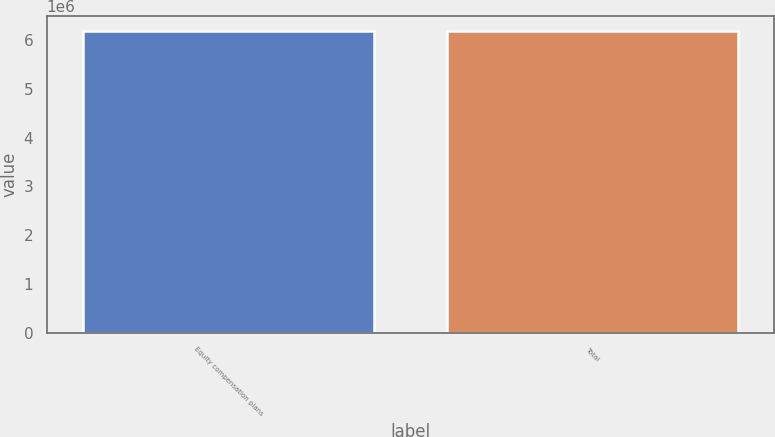Convert chart. <chart><loc_0><loc_0><loc_500><loc_500><bar_chart><fcel>Equity compensation plans<fcel>Total<nl><fcel>6.17506e+06<fcel>6.17506e+06<nl></chart> 